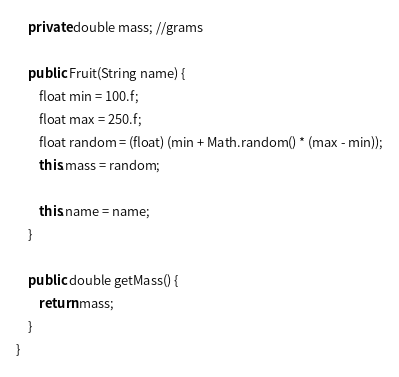Convert code to text. <code><loc_0><loc_0><loc_500><loc_500><_Java_>    private double mass; //grams

    public Fruit(String name) {
        float min = 100.f;
        float max = 250.f;
        float random = (float) (min + Math.random() * (max - min));
        this.mass = random;

        this.name = name;
    }

    public double getMass() {
        return mass;
    }
}
</code> 